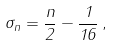Convert formula to latex. <formula><loc_0><loc_0><loc_500><loc_500>\sigma _ { n } = \frac { n } { 2 } - \frac { 1 } { 1 6 } \, ,</formula> 